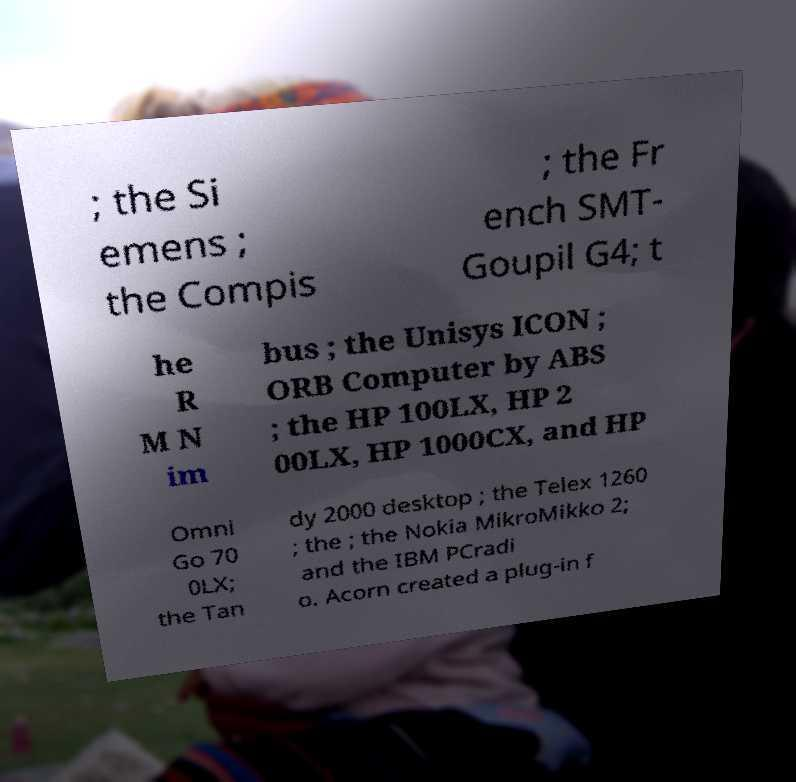Could you extract and type out the text from this image? ; the Si emens ; the Compis ; the Fr ench SMT- Goupil G4; t he R M N im bus ; the Unisys ICON ; ORB Computer by ABS ; the HP 100LX, HP 2 00LX, HP 1000CX, and HP Omni Go 70 0LX; the Tan dy 2000 desktop ; the Telex 1260 ; the ; the Nokia MikroMikko 2; and the IBM PCradi o. Acorn created a plug-in f 